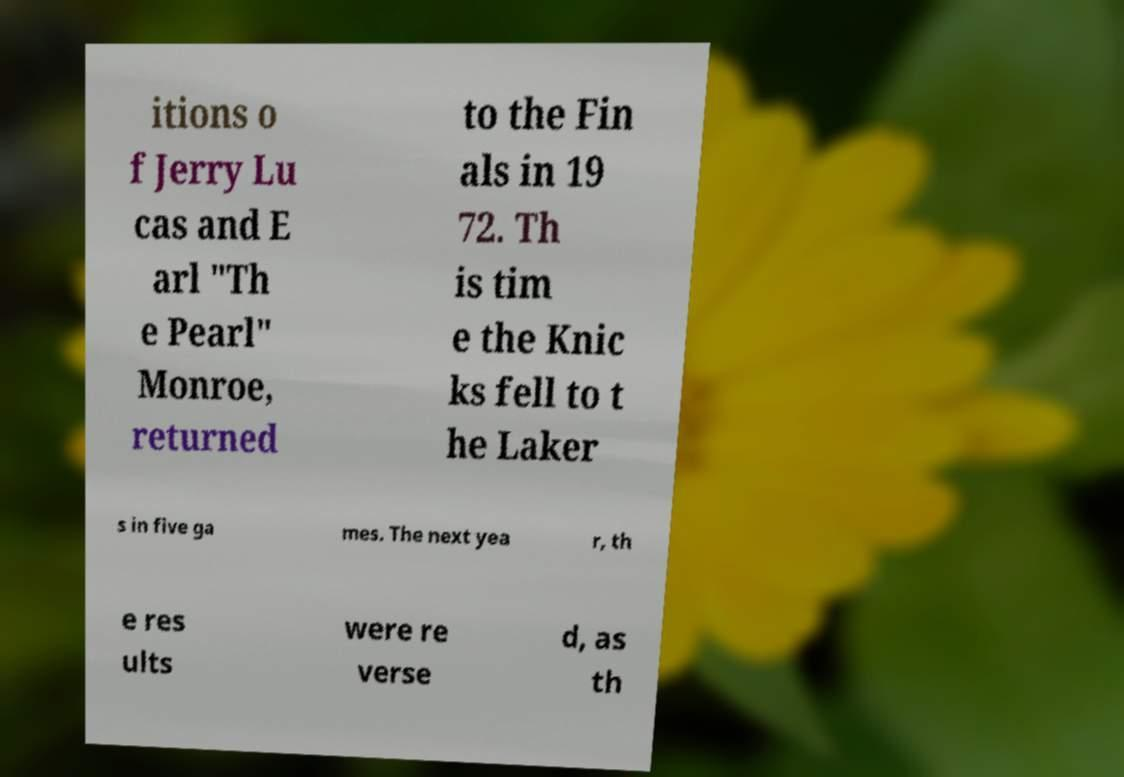Can you read and provide the text displayed in the image?This photo seems to have some interesting text. Can you extract and type it out for me? itions o f Jerry Lu cas and E arl "Th e Pearl" Monroe, returned to the Fin als in 19 72. Th is tim e the Knic ks fell to t he Laker s in five ga mes. The next yea r, th e res ults were re verse d, as th 